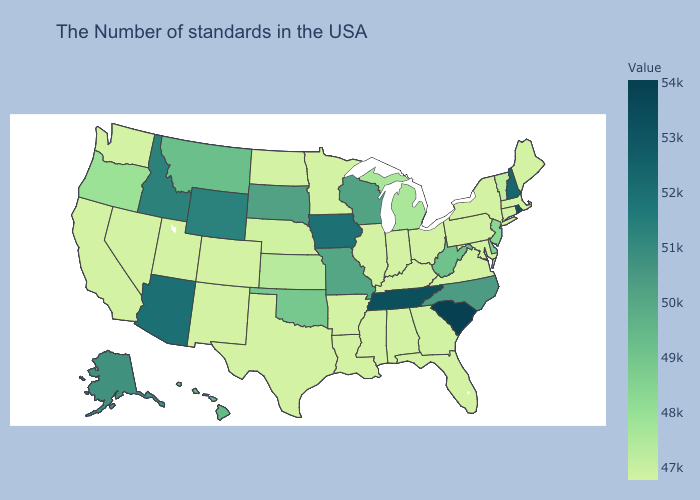Does Georgia have the highest value in the South?
Short answer required. No. Does the map have missing data?
Concise answer only. No. Which states have the lowest value in the USA?
Short answer required. Maine, Massachusetts, Connecticut, New York, Maryland, Pennsylvania, Virginia, Ohio, Florida, Kentucky, Indiana, Alabama, Illinois, Mississippi, Louisiana, Arkansas, Minnesota, Texas, North Dakota, Colorado, New Mexico, Utah, Nevada, California, Washington. Which states have the highest value in the USA?
Write a very short answer. South Carolina. Among the states that border Virginia , which have the highest value?
Concise answer only. Tennessee. Does Alabama have the lowest value in the USA?
Give a very brief answer. Yes. Does the map have missing data?
Concise answer only. No. 